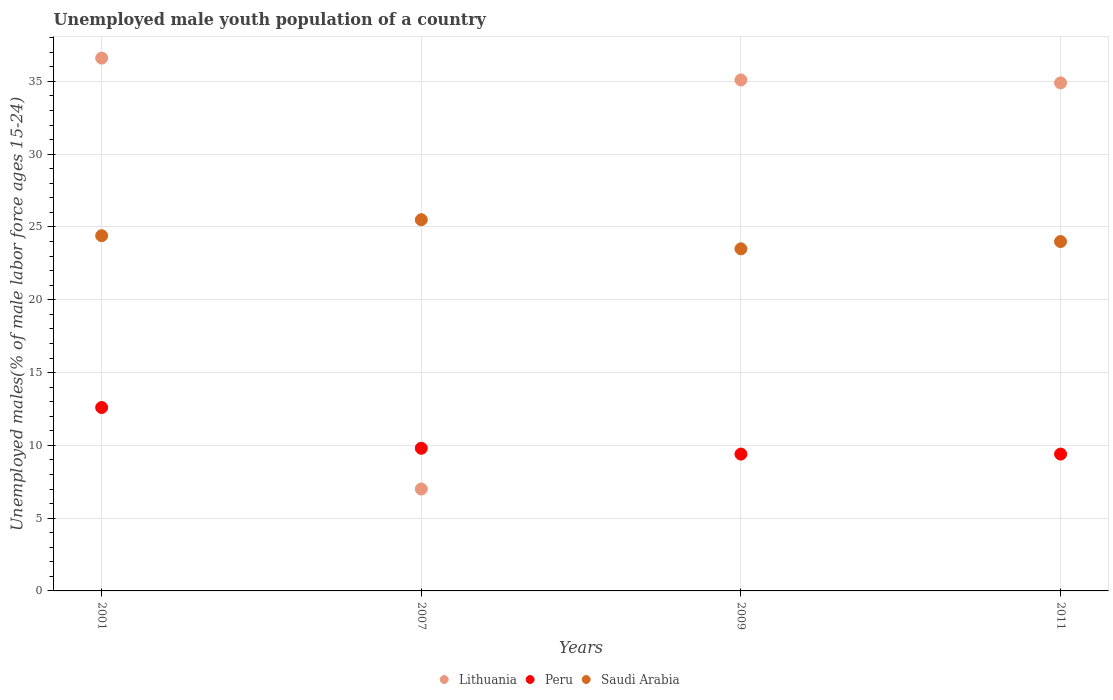How many different coloured dotlines are there?
Your response must be concise. 3. Is the number of dotlines equal to the number of legend labels?
Provide a short and direct response. Yes. What is the percentage of unemployed male youth population in Saudi Arabia in 2009?
Give a very brief answer. 23.5. Across all years, what is the maximum percentage of unemployed male youth population in Peru?
Ensure brevity in your answer.  12.6. Across all years, what is the minimum percentage of unemployed male youth population in Saudi Arabia?
Ensure brevity in your answer.  23.5. In which year was the percentage of unemployed male youth population in Lithuania maximum?
Offer a very short reply. 2001. What is the total percentage of unemployed male youth population in Lithuania in the graph?
Offer a very short reply. 113.6. What is the difference between the percentage of unemployed male youth population in Saudi Arabia in 2007 and the percentage of unemployed male youth population in Peru in 2009?
Make the answer very short. 16.1. What is the average percentage of unemployed male youth population in Peru per year?
Make the answer very short. 10.3. In the year 2011, what is the difference between the percentage of unemployed male youth population in Peru and percentage of unemployed male youth population in Lithuania?
Provide a short and direct response. -25.5. What is the ratio of the percentage of unemployed male youth population in Saudi Arabia in 2001 to that in 2011?
Your answer should be very brief. 1.02. What is the difference between the highest and the second highest percentage of unemployed male youth population in Lithuania?
Offer a very short reply. 1.5. What is the difference between the highest and the lowest percentage of unemployed male youth population in Peru?
Offer a terse response. 3.2. Is the sum of the percentage of unemployed male youth population in Lithuania in 2001 and 2011 greater than the maximum percentage of unemployed male youth population in Saudi Arabia across all years?
Give a very brief answer. Yes. Is it the case that in every year, the sum of the percentage of unemployed male youth population in Peru and percentage of unemployed male youth population in Lithuania  is greater than the percentage of unemployed male youth population in Saudi Arabia?
Ensure brevity in your answer.  No. Does the percentage of unemployed male youth population in Saudi Arabia monotonically increase over the years?
Offer a terse response. No. Is the percentage of unemployed male youth population in Saudi Arabia strictly less than the percentage of unemployed male youth population in Lithuania over the years?
Give a very brief answer. No. How many dotlines are there?
Give a very brief answer. 3. How many years are there in the graph?
Your answer should be very brief. 4. What is the difference between two consecutive major ticks on the Y-axis?
Your response must be concise. 5. Are the values on the major ticks of Y-axis written in scientific E-notation?
Offer a terse response. No. How many legend labels are there?
Give a very brief answer. 3. What is the title of the graph?
Your answer should be very brief. Unemployed male youth population of a country. Does "Sierra Leone" appear as one of the legend labels in the graph?
Provide a short and direct response. No. What is the label or title of the X-axis?
Give a very brief answer. Years. What is the label or title of the Y-axis?
Provide a succinct answer. Unemployed males(% of male labor force ages 15-24). What is the Unemployed males(% of male labor force ages 15-24) in Lithuania in 2001?
Your answer should be compact. 36.6. What is the Unemployed males(% of male labor force ages 15-24) of Peru in 2001?
Provide a succinct answer. 12.6. What is the Unemployed males(% of male labor force ages 15-24) in Saudi Arabia in 2001?
Offer a terse response. 24.4. What is the Unemployed males(% of male labor force ages 15-24) of Peru in 2007?
Offer a terse response. 9.8. What is the Unemployed males(% of male labor force ages 15-24) in Lithuania in 2009?
Your answer should be very brief. 35.1. What is the Unemployed males(% of male labor force ages 15-24) of Peru in 2009?
Ensure brevity in your answer.  9.4. What is the Unemployed males(% of male labor force ages 15-24) in Lithuania in 2011?
Give a very brief answer. 34.9. What is the Unemployed males(% of male labor force ages 15-24) in Peru in 2011?
Make the answer very short. 9.4. Across all years, what is the maximum Unemployed males(% of male labor force ages 15-24) of Lithuania?
Make the answer very short. 36.6. Across all years, what is the maximum Unemployed males(% of male labor force ages 15-24) of Peru?
Make the answer very short. 12.6. Across all years, what is the minimum Unemployed males(% of male labor force ages 15-24) in Lithuania?
Make the answer very short. 7. Across all years, what is the minimum Unemployed males(% of male labor force ages 15-24) of Peru?
Keep it short and to the point. 9.4. What is the total Unemployed males(% of male labor force ages 15-24) of Lithuania in the graph?
Make the answer very short. 113.6. What is the total Unemployed males(% of male labor force ages 15-24) of Peru in the graph?
Make the answer very short. 41.2. What is the total Unemployed males(% of male labor force ages 15-24) in Saudi Arabia in the graph?
Offer a terse response. 97.4. What is the difference between the Unemployed males(% of male labor force ages 15-24) in Lithuania in 2001 and that in 2007?
Ensure brevity in your answer.  29.6. What is the difference between the Unemployed males(% of male labor force ages 15-24) in Saudi Arabia in 2001 and that in 2007?
Your response must be concise. -1.1. What is the difference between the Unemployed males(% of male labor force ages 15-24) of Lithuania in 2001 and that in 2011?
Offer a terse response. 1.7. What is the difference between the Unemployed males(% of male labor force ages 15-24) of Peru in 2001 and that in 2011?
Offer a very short reply. 3.2. What is the difference between the Unemployed males(% of male labor force ages 15-24) in Saudi Arabia in 2001 and that in 2011?
Your answer should be compact. 0.4. What is the difference between the Unemployed males(% of male labor force ages 15-24) of Lithuania in 2007 and that in 2009?
Ensure brevity in your answer.  -28.1. What is the difference between the Unemployed males(% of male labor force ages 15-24) in Saudi Arabia in 2007 and that in 2009?
Provide a short and direct response. 2. What is the difference between the Unemployed males(% of male labor force ages 15-24) in Lithuania in 2007 and that in 2011?
Your answer should be compact. -27.9. What is the difference between the Unemployed males(% of male labor force ages 15-24) of Peru in 2007 and that in 2011?
Give a very brief answer. 0.4. What is the difference between the Unemployed males(% of male labor force ages 15-24) of Saudi Arabia in 2007 and that in 2011?
Offer a terse response. 1.5. What is the difference between the Unemployed males(% of male labor force ages 15-24) of Lithuania in 2009 and that in 2011?
Your answer should be compact. 0.2. What is the difference between the Unemployed males(% of male labor force ages 15-24) in Peru in 2009 and that in 2011?
Your answer should be compact. 0. What is the difference between the Unemployed males(% of male labor force ages 15-24) in Lithuania in 2001 and the Unemployed males(% of male labor force ages 15-24) in Peru in 2007?
Make the answer very short. 26.8. What is the difference between the Unemployed males(% of male labor force ages 15-24) of Lithuania in 2001 and the Unemployed males(% of male labor force ages 15-24) of Saudi Arabia in 2007?
Offer a very short reply. 11.1. What is the difference between the Unemployed males(% of male labor force ages 15-24) of Lithuania in 2001 and the Unemployed males(% of male labor force ages 15-24) of Peru in 2009?
Offer a very short reply. 27.2. What is the difference between the Unemployed males(% of male labor force ages 15-24) in Lithuania in 2001 and the Unemployed males(% of male labor force ages 15-24) in Saudi Arabia in 2009?
Make the answer very short. 13.1. What is the difference between the Unemployed males(% of male labor force ages 15-24) in Peru in 2001 and the Unemployed males(% of male labor force ages 15-24) in Saudi Arabia in 2009?
Provide a succinct answer. -10.9. What is the difference between the Unemployed males(% of male labor force ages 15-24) in Lithuania in 2001 and the Unemployed males(% of male labor force ages 15-24) in Peru in 2011?
Your response must be concise. 27.2. What is the difference between the Unemployed males(% of male labor force ages 15-24) of Lithuania in 2001 and the Unemployed males(% of male labor force ages 15-24) of Saudi Arabia in 2011?
Give a very brief answer. 12.6. What is the difference between the Unemployed males(% of male labor force ages 15-24) of Lithuania in 2007 and the Unemployed males(% of male labor force ages 15-24) of Peru in 2009?
Offer a terse response. -2.4. What is the difference between the Unemployed males(% of male labor force ages 15-24) in Lithuania in 2007 and the Unemployed males(% of male labor force ages 15-24) in Saudi Arabia in 2009?
Provide a succinct answer. -16.5. What is the difference between the Unemployed males(% of male labor force ages 15-24) of Peru in 2007 and the Unemployed males(% of male labor force ages 15-24) of Saudi Arabia in 2009?
Keep it short and to the point. -13.7. What is the difference between the Unemployed males(% of male labor force ages 15-24) of Lithuania in 2007 and the Unemployed males(% of male labor force ages 15-24) of Saudi Arabia in 2011?
Your answer should be very brief. -17. What is the difference between the Unemployed males(% of male labor force ages 15-24) of Peru in 2007 and the Unemployed males(% of male labor force ages 15-24) of Saudi Arabia in 2011?
Give a very brief answer. -14.2. What is the difference between the Unemployed males(% of male labor force ages 15-24) of Lithuania in 2009 and the Unemployed males(% of male labor force ages 15-24) of Peru in 2011?
Keep it short and to the point. 25.7. What is the difference between the Unemployed males(% of male labor force ages 15-24) in Peru in 2009 and the Unemployed males(% of male labor force ages 15-24) in Saudi Arabia in 2011?
Provide a short and direct response. -14.6. What is the average Unemployed males(% of male labor force ages 15-24) of Lithuania per year?
Give a very brief answer. 28.4. What is the average Unemployed males(% of male labor force ages 15-24) of Saudi Arabia per year?
Give a very brief answer. 24.35. In the year 2001, what is the difference between the Unemployed males(% of male labor force ages 15-24) of Peru and Unemployed males(% of male labor force ages 15-24) of Saudi Arabia?
Your response must be concise. -11.8. In the year 2007, what is the difference between the Unemployed males(% of male labor force ages 15-24) in Lithuania and Unemployed males(% of male labor force ages 15-24) in Peru?
Offer a terse response. -2.8. In the year 2007, what is the difference between the Unemployed males(% of male labor force ages 15-24) of Lithuania and Unemployed males(% of male labor force ages 15-24) of Saudi Arabia?
Ensure brevity in your answer.  -18.5. In the year 2007, what is the difference between the Unemployed males(% of male labor force ages 15-24) in Peru and Unemployed males(% of male labor force ages 15-24) in Saudi Arabia?
Provide a succinct answer. -15.7. In the year 2009, what is the difference between the Unemployed males(% of male labor force ages 15-24) in Lithuania and Unemployed males(% of male labor force ages 15-24) in Peru?
Make the answer very short. 25.7. In the year 2009, what is the difference between the Unemployed males(% of male labor force ages 15-24) of Lithuania and Unemployed males(% of male labor force ages 15-24) of Saudi Arabia?
Give a very brief answer. 11.6. In the year 2009, what is the difference between the Unemployed males(% of male labor force ages 15-24) of Peru and Unemployed males(% of male labor force ages 15-24) of Saudi Arabia?
Your response must be concise. -14.1. In the year 2011, what is the difference between the Unemployed males(% of male labor force ages 15-24) of Peru and Unemployed males(% of male labor force ages 15-24) of Saudi Arabia?
Ensure brevity in your answer.  -14.6. What is the ratio of the Unemployed males(% of male labor force ages 15-24) of Lithuania in 2001 to that in 2007?
Provide a succinct answer. 5.23. What is the ratio of the Unemployed males(% of male labor force ages 15-24) of Saudi Arabia in 2001 to that in 2007?
Offer a terse response. 0.96. What is the ratio of the Unemployed males(% of male labor force ages 15-24) of Lithuania in 2001 to that in 2009?
Provide a short and direct response. 1.04. What is the ratio of the Unemployed males(% of male labor force ages 15-24) in Peru in 2001 to that in 2009?
Provide a short and direct response. 1.34. What is the ratio of the Unemployed males(% of male labor force ages 15-24) in Saudi Arabia in 2001 to that in 2009?
Make the answer very short. 1.04. What is the ratio of the Unemployed males(% of male labor force ages 15-24) in Lithuania in 2001 to that in 2011?
Provide a short and direct response. 1.05. What is the ratio of the Unemployed males(% of male labor force ages 15-24) of Peru in 2001 to that in 2011?
Offer a terse response. 1.34. What is the ratio of the Unemployed males(% of male labor force ages 15-24) of Saudi Arabia in 2001 to that in 2011?
Ensure brevity in your answer.  1.02. What is the ratio of the Unemployed males(% of male labor force ages 15-24) of Lithuania in 2007 to that in 2009?
Offer a terse response. 0.2. What is the ratio of the Unemployed males(% of male labor force ages 15-24) in Peru in 2007 to that in 2009?
Your response must be concise. 1.04. What is the ratio of the Unemployed males(% of male labor force ages 15-24) in Saudi Arabia in 2007 to that in 2009?
Provide a short and direct response. 1.09. What is the ratio of the Unemployed males(% of male labor force ages 15-24) in Lithuania in 2007 to that in 2011?
Your answer should be very brief. 0.2. What is the ratio of the Unemployed males(% of male labor force ages 15-24) in Peru in 2007 to that in 2011?
Provide a short and direct response. 1.04. What is the ratio of the Unemployed males(% of male labor force ages 15-24) of Saudi Arabia in 2007 to that in 2011?
Keep it short and to the point. 1.06. What is the ratio of the Unemployed males(% of male labor force ages 15-24) in Saudi Arabia in 2009 to that in 2011?
Your response must be concise. 0.98. What is the difference between the highest and the second highest Unemployed males(% of male labor force ages 15-24) of Lithuania?
Your answer should be compact. 1.5. What is the difference between the highest and the lowest Unemployed males(% of male labor force ages 15-24) in Lithuania?
Offer a very short reply. 29.6. 